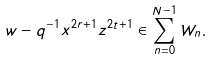Convert formula to latex. <formula><loc_0><loc_0><loc_500><loc_500>w - q ^ { - 1 } x ^ { 2 r + 1 } z ^ { 2 t + 1 } \in \sum _ { n = 0 } ^ { N - 1 } W _ { n } .</formula> 